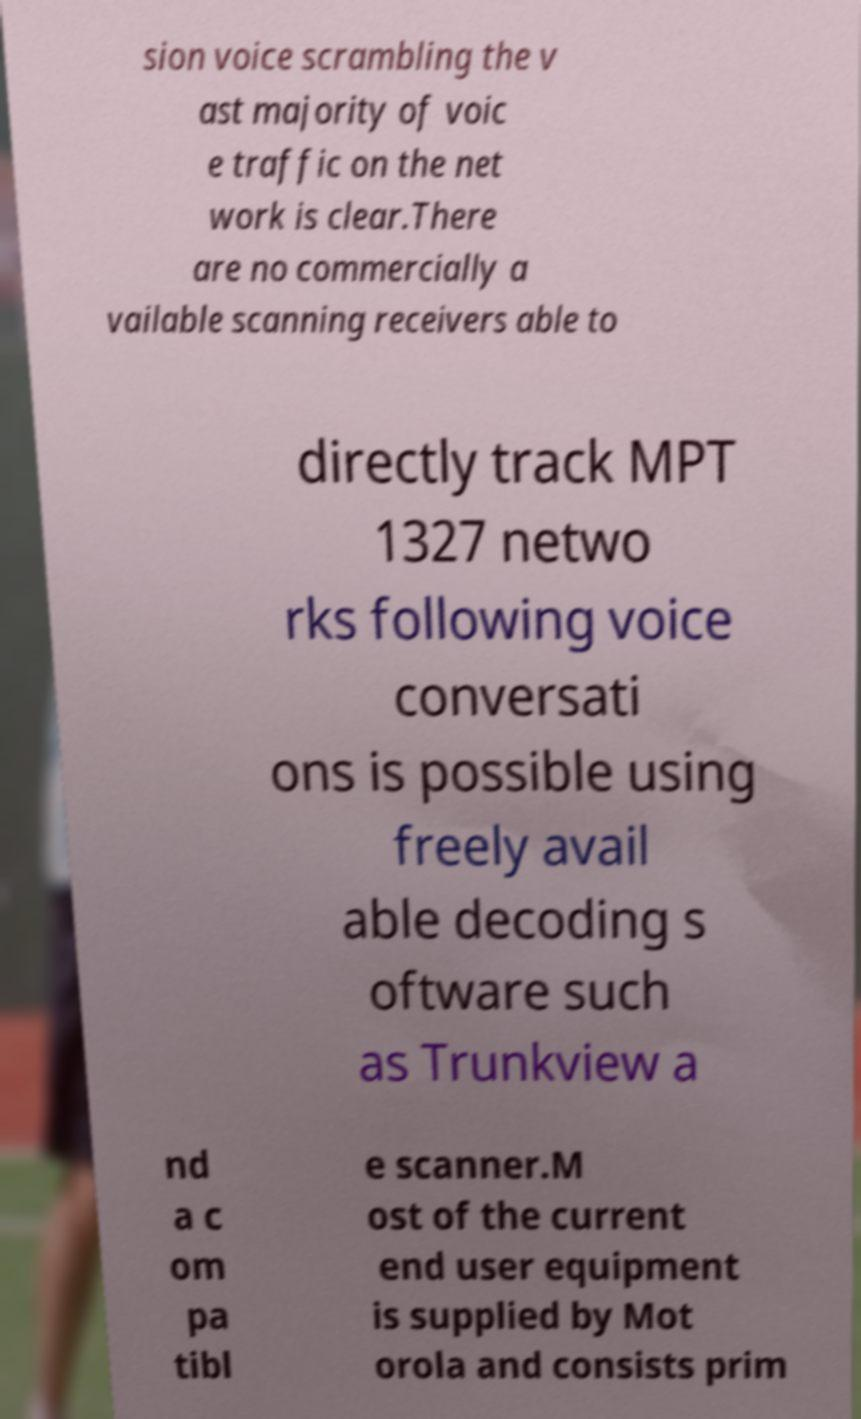Can you read and provide the text displayed in the image?This photo seems to have some interesting text. Can you extract and type it out for me? sion voice scrambling the v ast majority of voic e traffic on the net work is clear.There are no commercially a vailable scanning receivers able to directly track MPT 1327 netwo rks following voice conversati ons is possible using freely avail able decoding s oftware such as Trunkview a nd a c om pa tibl e scanner.M ost of the current end user equipment is supplied by Mot orola and consists prim 